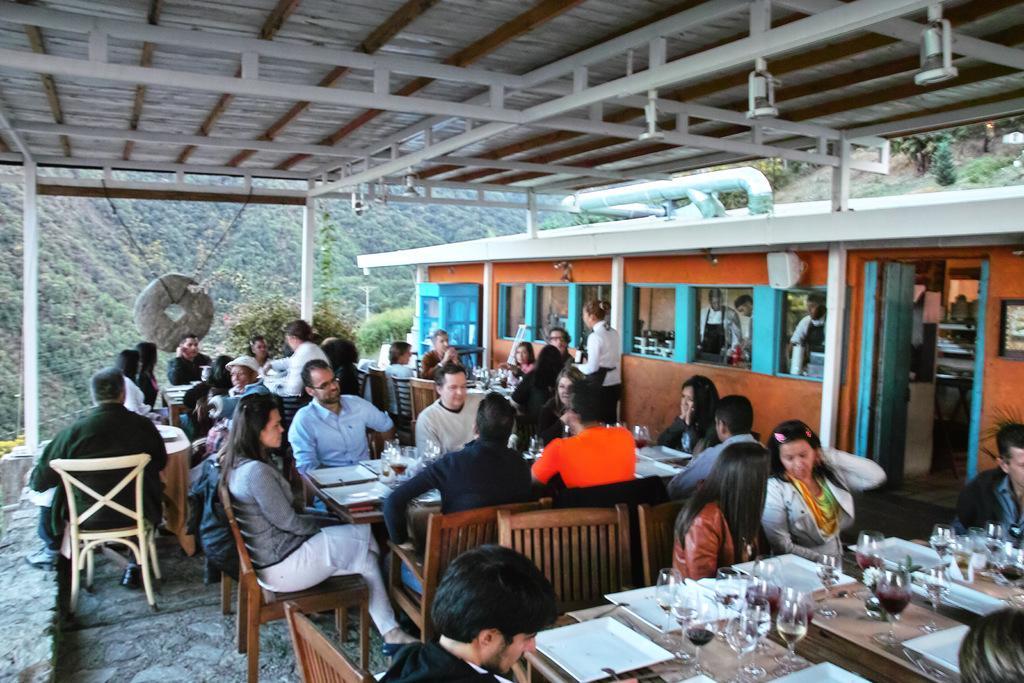How would you summarize this image in a sentence or two? In this picture we can see a group of people sitting on chair and in front of them there is table and on table we can see glasses, tray and on right side we can see mirror and reflection of them and in the background we can see hills with trees, pipes. 